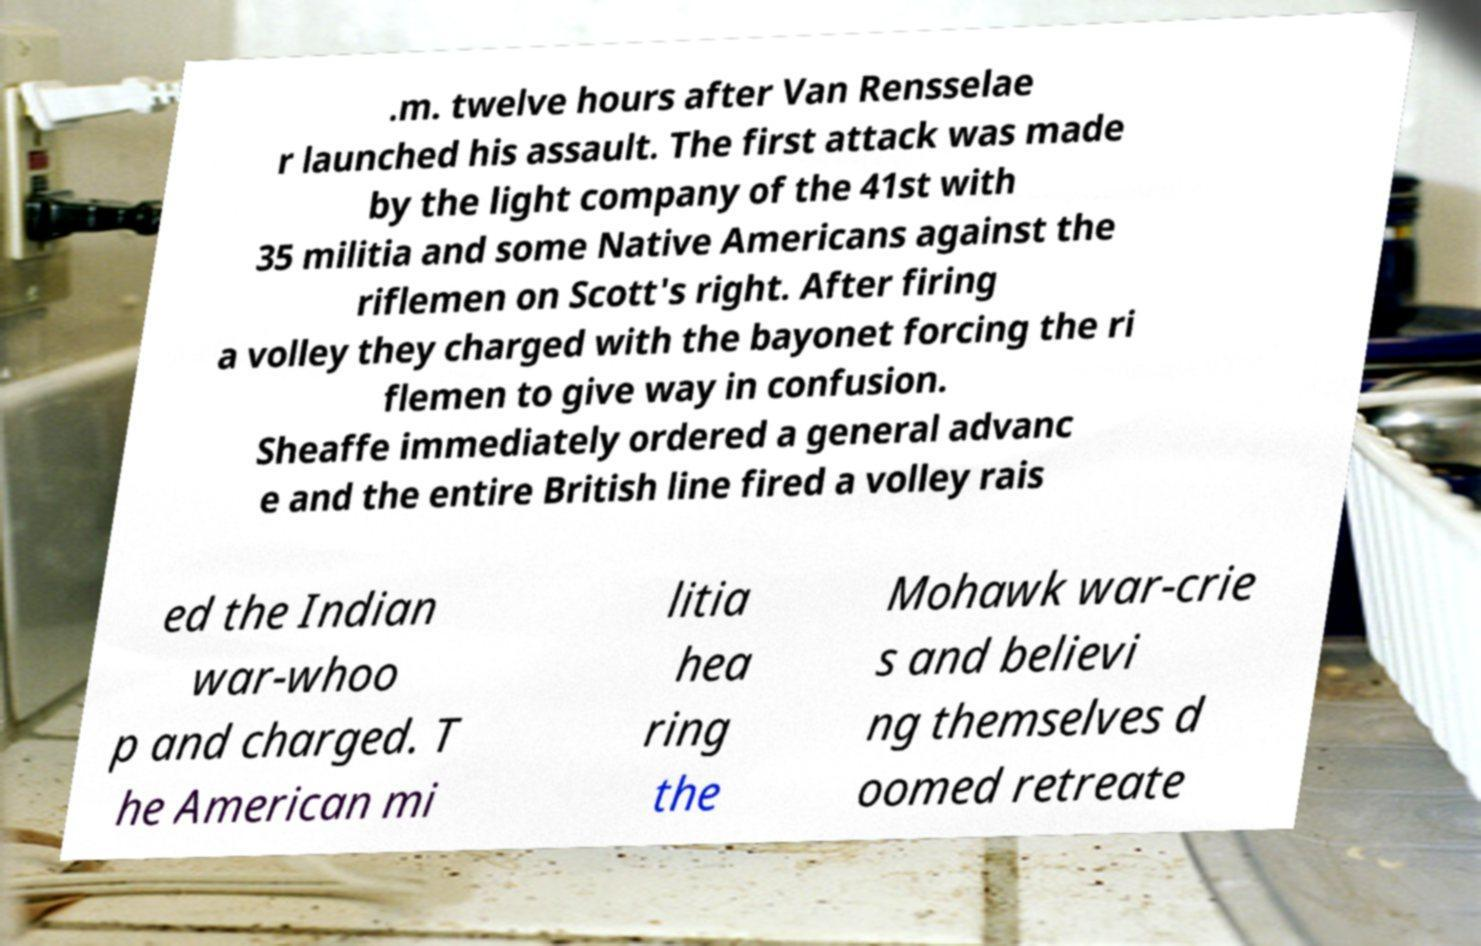There's text embedded in this image that I need extracted. Can you transcribe it verbatim? .m. twelve hours after Van Rensselae r launched his assault. The first attack was made by the light company of the 41st with 35 militia and some Native Americans against the riflemen on Scott's right. After firing a volley they charged with the bayonet forcing the ri flemen to give way in confusion. Sheaffe immediately ordered a general advanc e and the entire British line fired a volley rais ed the Indian war-whoo p and charged. T he American mi litia hea ring the Mohawk war-crie s and believi ng themselves d oomed retreate 